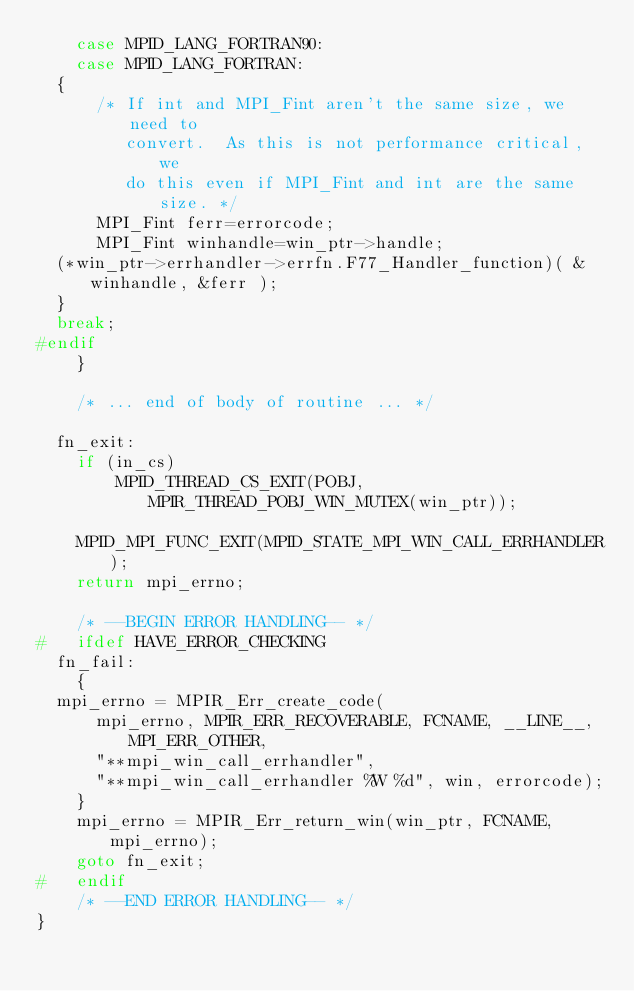<code> <loc_0><loc_0><loc_500><loc_500><_C_>    case MPID_LANG_FORTRAN90:
    case MPID_LANG_FORTRAN:
	{
	    /* If int and MPI_Fint aren't the same size, we need to 
	       convert.  As this is not performance critical, we
	       do this even if MPI_Fint and int are the same size. */
	    MPI_Fint ferr=errorcode;
	    MPI_Fint winhandle=win_ptr->handle;
	(*win_ptr->errhandler->errfn.F77_Handler_function)( &winhandle, &ferr );
	}
	break;
#endif
    }
    
    /* ... end of body of routine ... */

  fn_exit:
    if (in_cs)
        MPID_THREAD_CS_EXIT(POBJ, MPIR_THREAD_POBJ_WIN_MUTEX(win_ptr));

    MPID_MPI_FUNC_EXIT(MPID_STATE_MPI_WIN_CALL_ERRHANDLER);
    return mpi_errno;

    /* --BEGIN ERROR HANDLING-- */
#   ifdef HAVE_ERROR_CHECKING
  fn_fail:
    {
	mpi_errno = MPIR_Err_create_code(
	    mpi_errno, MPIR_ERR_RECOVERABLE, FCNAME, __LINE__, MPI_ERR_OTHER, 
	    "**mpi_win_call_errhandler", 
	    "**mpi_win_call_errhandler %W %d", win, errorcode);
    }
    mpi_errno = MPIR_Err_return_win(win_ptr, FCNAME, mpi_errno);
    goto fn_exit;
#   endif
    /* --END ERROR HANDLING-- */
}
</code> 